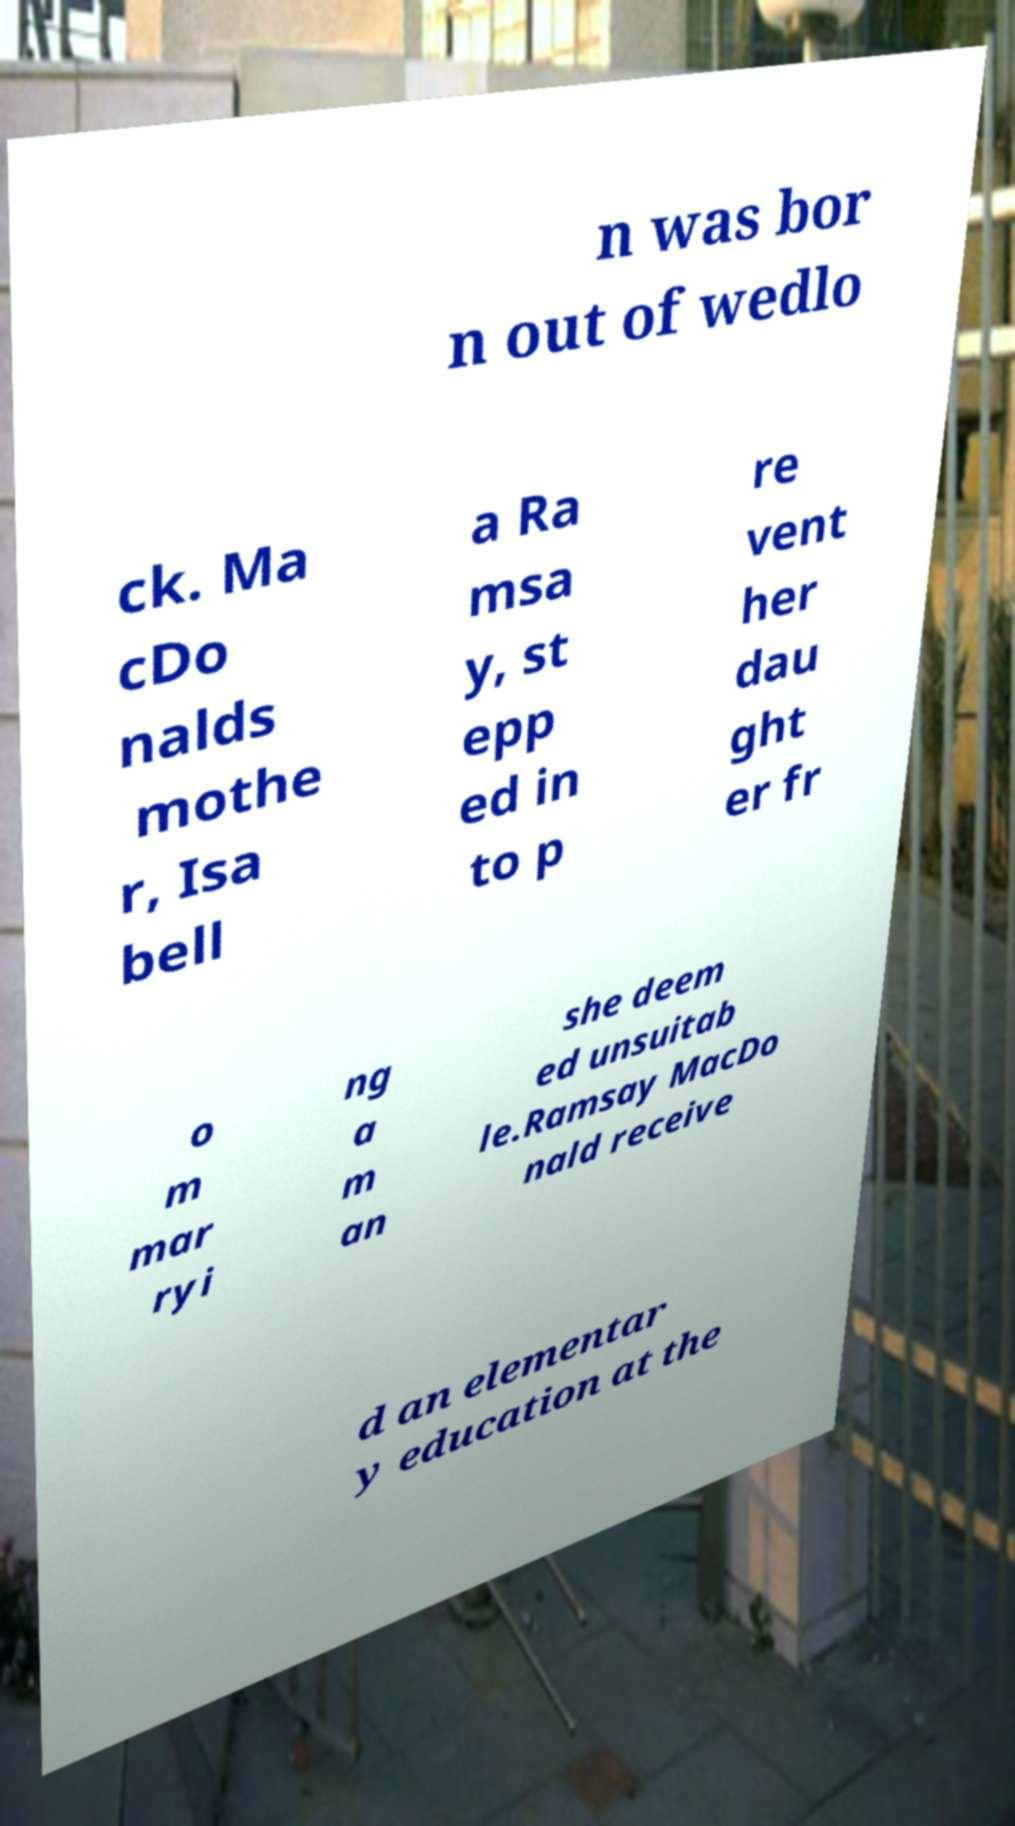There's text embedded in this image that I need extracted. Can you transcribe it verbatim? n was bor n out of wedlo ck. Ma cDo nalds mothe r, Isa bell a Ra msa y, st epp ed in to p re vent her dau ght er fr o m mar ryi ng a m an she deem ed unsuitab le.Ramsay MacDo nald receive d an elementar y education at the 